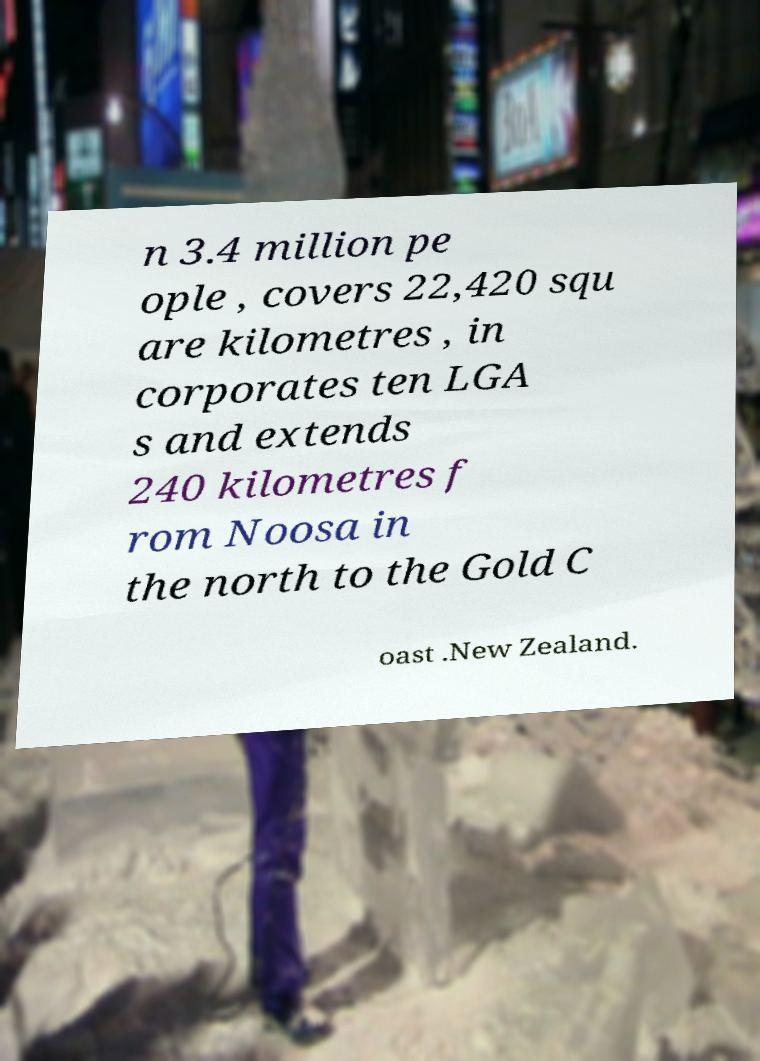There's text embedded in this image that I need extracted. Can you transcribe it verbatim? n 3.4 million pe ople , covers 22,420 squ are kilometres , in corporates ten LGA s and extends 240 kilometres f rom Noosa in the north to the Gold C oast .New Zealand. 